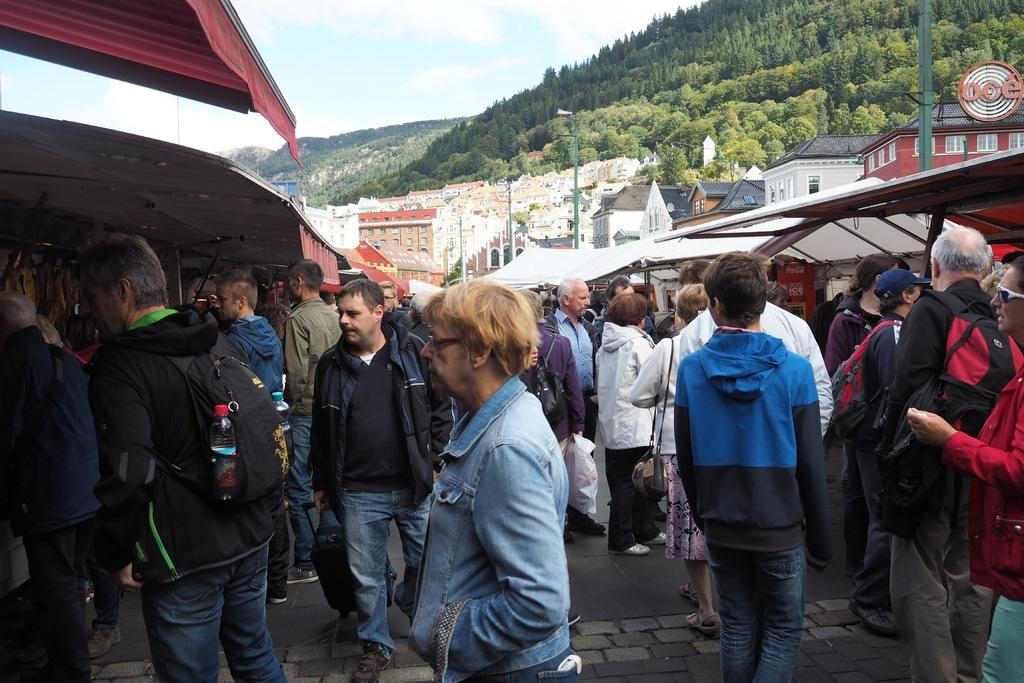How many people are in the group visible in the image? There is a group of people in the image, but the exact number cannot be determined from the provided facts. What are some people in the group carrying? Some people in the group are carrying bags. What can be seen in the background of the image? There are buildings, poles, trees, and the sky visible in the background of the image. Can you tell me which person in the group has the most visible vein in the image? There is no mention of veins or any medical information in the image, so it is not possible to answer that question. 